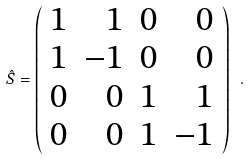<formula> <loc_0><loc_0><loc_500><loc_500>\hat { S } = \left ( \begin{array} { c r r r } 1 & 1 & 0 & 0 \\ 1 & - 1 & 0 & 0 \\ 0 & 0 & 1 & 1 \\ 0 & 0 & 1 & - 1 \end{array} \right ) \ .</formula> 